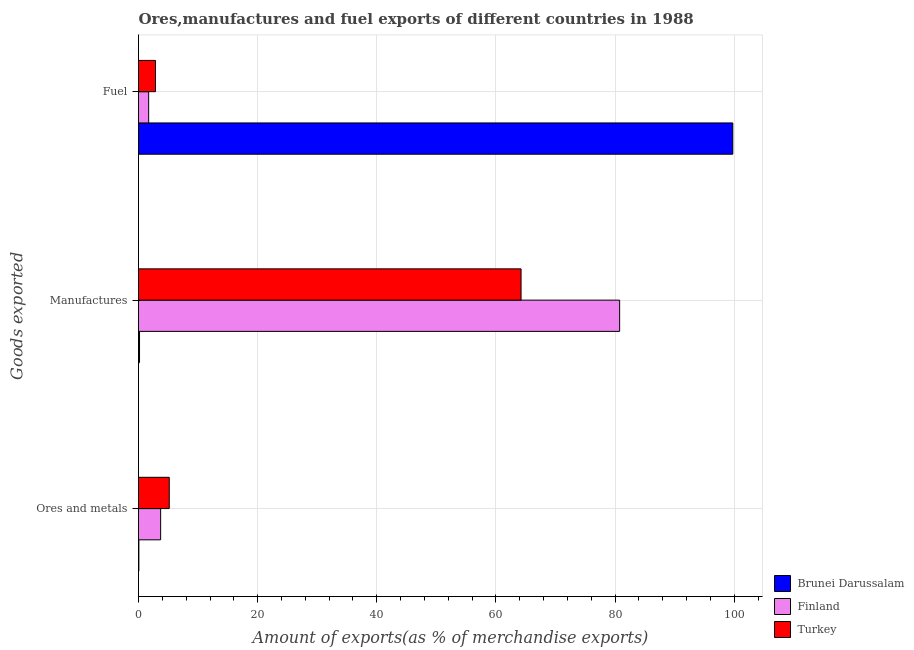How many groups of bars are there?
Offer a terse response. 3. Are the number of bars per tick equal to the number of legend labels?
Your answer should be very brief. Yes. Are the number of bars on each tick of the Y-axis equal?
Give a very brief answer. Yes. How many bars are there on the 1st tick from the bottom?
Give a very brief answer. 3. What is the label of the 3rd group of bars from the top?
Offer a terse response. Ores and metals. What is the percentage of manufactures exports in Brunei Darussalam?
Keep it short and to the point. 0.17. Across all countries, what is the maximum percentage of manufactures exports?
Your answer should be very brief. 80.76. Across all countries, what is the minimum percentage of ores and metals exports?
Your answer should be very brief. 0.06. In which country was the percentage of manufactures exports maximum?
Your answer should be compact. Finland. In which country was the percentage of manufactures exports minimum?
Your response must be concise. Brunei Darussalam. What is the total percentage of fuel exports in the graph?
Provide a succinct answer. 104.31. What is the difference between the percentage of manufactures exports in Brunei Darussalam and that in Turkey?
Your answer should be compact. -64.05. What is the difference between the percentage of manufactures exports in Finland and the percentage of fuel exports in Brunei Darussalam?
Ensure brevity in your answer.  -18.99. What is the average percentage of fuel exports per country?
Keep it short and to the point. 34.77. What is the difference between the percentage of manufactures exports and percentage of ores and metals exports in Finland?
Your answer should be compact. 77.05. In how many countries, is the percentage of ores and metals exports greater than 8 %?
Your answer should be compact. 0. What is the ratio of the percentage of ores and metals exports in Turkey to that in Finland?
Offer a terse response. 1.39. Is the difference between the percentage of fuel exports in Brunei Darussalam and Turkey greater than the difference between the percentage of manufactures exports in Brunei Darussalam and Turkey?
Ensure brevity in your answer.  Yes. What is the difference between the highest and the second highest percentage of ores and metals exports?
Your response must be concise. 1.45. What is the difference between the highest and the lowest percentage of manufactures exports?
Your answer should be compact. 80.59. Is the sum of the percentage of fuel exports in Finland and Turkey greater than the maximum percentage of manufactures exports across all countries?
Ensure brevity in your answer.  No. What does the 2nd bar from the top in Manufactures represents?
Keep it short and to the point. Finland. What does the 1st bar from the bottom in Fuel represents?
Provide a succinct answer. Brunei Darussalam. Is it the case that in every country, the sum of the percentage of ores and metals exports and percentage of manufactures exports is greater than the percentage of fuel exports?
Your response must be concise. No. How many bars are there?
Provide a succinct answer. 9. What is the difference between two consecutive major ticks on the X-axis?
Provide a short and direct response. 20. Are the values on the major ticks of X-axis written in scientific E-notation?
Ensure brevity in your answer.  No. Does the graph contain any zero values?
Your response must be concise. No. Where does the legend appear in the graph?
Keep it short and to the point. Bottom right. How many legend labels are there?
Give a very brief answer. 3. What is the title of the graph?
Offer a very short reply. Ores,manufactures and fuel exports of different countries in 1988. Does "Uganda" appear as one of the legend labels in the graph?
Make the answer very short. No. What is the label or title of the X-axis?
Offer a very short reply. Amount of exports(as % of merchandise exports). What is the label or title of the Y-axis?
Offer a very short reply. Goods exported. What is the Amount of exports(as % of merchandise exports) in Brunei Darussalam in Ores and metals?
Offer a terse response. 0.06. What is the Amount of exports(as % of merchandise exports) of Finland in Ores and metals?
Your answer should be very brief. 3.72. What is the Amount of exports(as % of merchandise exports) of Turkey in Ores and metals?
Provide a succinct answer. 5.16. What is the Amount of exports(as % of merchandise exports) of Brunei Darussalam in Manufactures?
Your answer should be compact. 0.17. What is the Amount of exports(as % of merchandise exports) in Finland in Manufactures?
Give a very brief answer. 80.76. What is the Amount of exports(as % of merchandise exports) of Turkey in Manufactures?
Your answer should be very brief. 64.22. What is the Amount of exports(as % of merchandise exports) in Brunei Darussalam in Fuel?
Ensure brevity in your answer.  99.76. What is the Amount of exports(as % of merchandise exports) in Finland in Fuel?
Offer a very short reply. 1.7. What is the Amount of exports(as % of merchandise exports) in Turkey in Fuel?
Your response must be concise. 2.85. Across all Goods exported, what is the maximum Amount of exports(as % of merchandise exports) of Brunei Darussalam?
Make the answer very short. 99.76. Across all Goods exported, what is the maximum Amount of exports(as % of merchandise exports) in Finland?
Make the answer very short. 80.76. Across all Goods exported, what is the maximum Amount of exports(as % of merchandise exports) in Turkey?
Your answer should be compact. 64.22. Across all Goods exported, what is the minimum Amount of exports(as % of merchandise exports) in Brunei Darussalam?
Your answer should be very brief. 0.06. Across all Goods exported, what is the minimum Amount of exports(as % of merchandise exports) in Finland?
Offer a terse response. 1.7. Across all Goods exported, what is the minimum Amount of exports(as % of merchandise exports) in Turkey?
Provide a short and direct response. 2.85. What is the total Amount of exports(as % of merchandise exports) in Brunei Darussalam in the graph?
Give a very brief answer. 99.99. What is the total Amount of exports(as % of merchandise exports) of Finland in the graph?
Your answer should be very brief. 86.18. What is the total Amount of exports(as % of merchandise exports) of Turkey in the graph?
Give a very brief answer. 72.23. What is the difference between the Amount of exports(as % of merchandise exports) in Brunei Darussalam in Ores and metals and that in Manufactures?
Your answer should be very brief. -0.11. What is the difference between the Amount of exports(as % of merchandise exports) of Finland in Ores and metals and that in Manufactures?
Keep it short and to the point. -77.05. What is the difference between the Amount of exports(as % of merchandise exports) of Turkey in Ores and metals and that in Manufactures?
Your response must be concise. -59.05. What is the difference between the Amount of exports(as % of merchandise exports) of Brunei Darussalam in Ores and metals and that in Fuel?
Your answer should be compact. -99.7. What is the difference between the Amount of exports(as % of merchandise exports) in Finland in Ores and metals and that in Fuel?
Ensure brevity in your answer.  2.01. What is the difference between the Amount of exports(as % of merchandise exports) in Turkey in Ores and metals and that in Fuel?
Provide a succinct answer. 2.31. What is the difference between the Amount of exports(as % of merchandise exports) in Brunei Darussalam in Manufactures and that in Fuel?
Your answer should be compact. -99.59. What is the difference between the Amount of exports(as % of merchandise exports) of Finland in Manufactures and that in Fuel?
Your answer should be compact. 79.06. What is the difference between the Amount of exports(as % of merchandise exports) in Turkey in Manufactures and that in Fuel?
Give a very brief answer. 61.37. What is the difference between the Amount of exports(as % of merchandise exports) of Brunei Darussalam in Ores and metals and the Amount of exports(as % of merchandise exports) of Finland in Manufactures?
Offer a terse response. -80.7. What is the difference between the Amount of exports(as % of merchandise exports) of Brunei Darussalam in Ores and metals and the Amount of exports(as % of merchandise exports) of Turkey in Manufactures?
Keep it short and to the point. -64.15. What is the difference between the Amount of exports(as % of merchandise exports) in Finland in Ores and metals and the Amount of exports(as % of merchandise exports) in Turkey in Manufactures?
Make the answer very short. -60.5. What is the difference between the Amount of exports(as % of merchandise exports) in Brunei Darussalam in Ores and metals and the Amount of exports(as % of merchandise exports) in Finland in Fuel?
Give a very brief answer. -1.64. What is the difference between the Amount of exports(as % of merchandise exports) of Brunei Darussalam in Ores and metals and the Amount of exports(as % of merchandise exports) of Turkey in Fuel?
Ensure brevity in your answer.  -2.79. What is the difference between the Amount of exports(as % of merchandise exports) of Finland in Ores and metals and the Amount of exports(as % of merchandise exports) of Turkey in Fuel?
Make the answer very short. 0.87. What is the difference between the Amount of exports(as % of merchandise exports) in Brunei Darussalam in Manufactures and the Amount of exports(as % of merchandise exports) in Finland in Fuel?
Ensure brevity in your answer.  -1.53. What is the difference between the Amount of exports(as % of merchandise exports) of Brunei Darussalam in Manufactures and the Amount of exports(as % of merchandise exports) of Turkey in Fuel?
Your answer should be very brief. -2.68. What is the difference between the Amount of exports(as % of merchandise exports) of Finland in Manufactures and the Amount of exports(as % of merchandise exports) of Turkey in Fuel?
Your response must be concise. 77.91. What is the average Amount of exports(as % of merchandise exports) in Brunei Darussalam per Goods exported?
Keep it short and to the point. 33.33. What is the average Amount of exports(as % of merchandise exports) in Finland per Goods exported?
Provide a succinct answer. 28.73. What is the average Amount of exports(as % of merchandise exports) in Turkey per Goods exported?
Your response must be concise. 24.08. What is the difference between the Amount of exports(as % of merchandise exports) in Brunei Darussalam and Amount of exports(as % of merchandise exports) in Finland in Ores and metals?
Your response must be concise. -3.65. What is the difference between the Amount of exports(as % of merchandise exports) in Brunei Darussalam and Amount of exports(as % of merchandise exports) in Turkey in Ores and metals?
Your answer should be compact. -5.1. What is the difference between the Amount of exports(as % of merchandise exports) in Finland and Amount of exports(as % of merchandise exports) in Turkey in Ores and metals?
Make the answer very short. -1.45. What is the difference between the Amount of exports(as % of merchandise exports) in Brunei Darussalam and Amount of exports(as % of merchandise exports) in Finland in Manufactures?
Keep it short and to the point. -80.59. What is the difference between the Amount of exports(as % of merchandise exports) of Brunei Darussalam and Amount of exports(as % of merchandise exports) of Turkey in Manufactures?
Provide a short and direct response. -64.05. What is the difference between the Amount of exports(as % of merchandise exports) in Finland and Amount of exports(as % of merchandise exports) in Turkey in Manufactures?
Offer a very short reply. 16.55. What is the difference between the Amount of exports(as % of merchandise exports) in Brunei Darussalam and Amount of exports(as % of merchandise exports) in Finland in Fuel?
Ensure brevity in your answer.  98.05. What is the difference between the Amount of exports(as % of merchandise exports) of Brunei Darussalam and Amount of exports(as % of merchandise exports) of Turkey in Fuel?
Your response must be concise. 96.91. What is the difference between the Amount of exports(as % of merchandise exports) in Finland and Amount of exports(as % of merchandise exports) in Turkey in Fuel?
Give a very brief answer. -1.14. What is the ratio of the Amount of exports(as % of merchandise exports) of Brunei Darussalam in Ores and metals to that in Manufactures?
Provide a short and direct response. 0.36. What is the ratio of the Amount of exports(as % of merchandise exports) in Finland in Ores and metals to that in Manufactures?
Your response must be concise. 0.05. What is the ratio of the Amount of exports(as % of merchandise exports) in Turkey in Ores and metals to that in Manufactures?
Your answer should be compact. 0.08. What is the ratio of the Amount of exports(as % of merchandise exports) in Brunei Darussalam in Ores and metals to that in Fuel?
Provide a short and direct response. 0. What is the ratio of the Amount of exports(as % of merchandise exports) in Finland in Ores and metals to that in Fuel?
Keep it short and to the point. 2.18. What is the ratio of the Amount of exports(as % of merchandise exports) in Turkey in Ores and metals to that in Fuel?
Offer a terse response. 1.81. What is the ratio of the Amount of exports(as % of merchandise exports) of Brunei Darussalam in Manufactures to that in Fuel?
Provide a short and direct response. 0. What is the ratio of the Amount of exports(as % of merchandise exports) of Finland in Manufactures to that in Fuel?
Offer a very short reply. 47.38. What is the ratio of the Amount of exports(as % of merchandise exports) of Turkey in Manufactures to that in Fuel?
Provide a short and direct response. 22.54. What is the difference between the highest and the second highest Amount of exports(as % of merchandise exports) of Brunei Darussalam?
Give a very brief answer. 99.59. What is the difference between the highest and the second highest Amount of exports(as % of merchandise exports) of Finland?
Your answer should be compact. 77.05. What is the difference between the highest and the second highest Amount of exports(as % of merchandise exports) in Turkey?
Give a very brief answer. 59.05. What is the difference between the highest and the lowest Amount of exports(as % of merchandise exports) in Brunei Darussalam?
Offer a terse response. 99.7. What is the difference between the highest and the lowest Amount of exports(as % of merchandise exports) in Finland?
Offer a very short reply. 79.06. What is the difference between the highest and the lowest Amount of exports(as % of merchandise exports) in Turkey?
Ensure brevity in your answer.  61.37. 